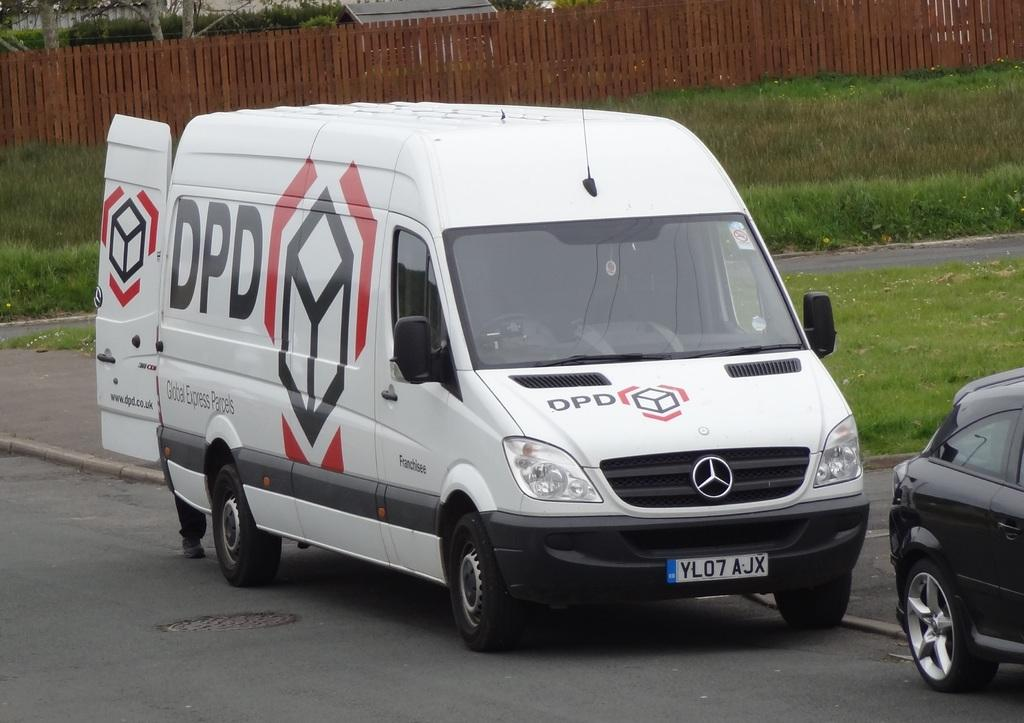<image>
Create a compact narrative representing the image presented. A Mercedes van that says DPD on the side and the front. 